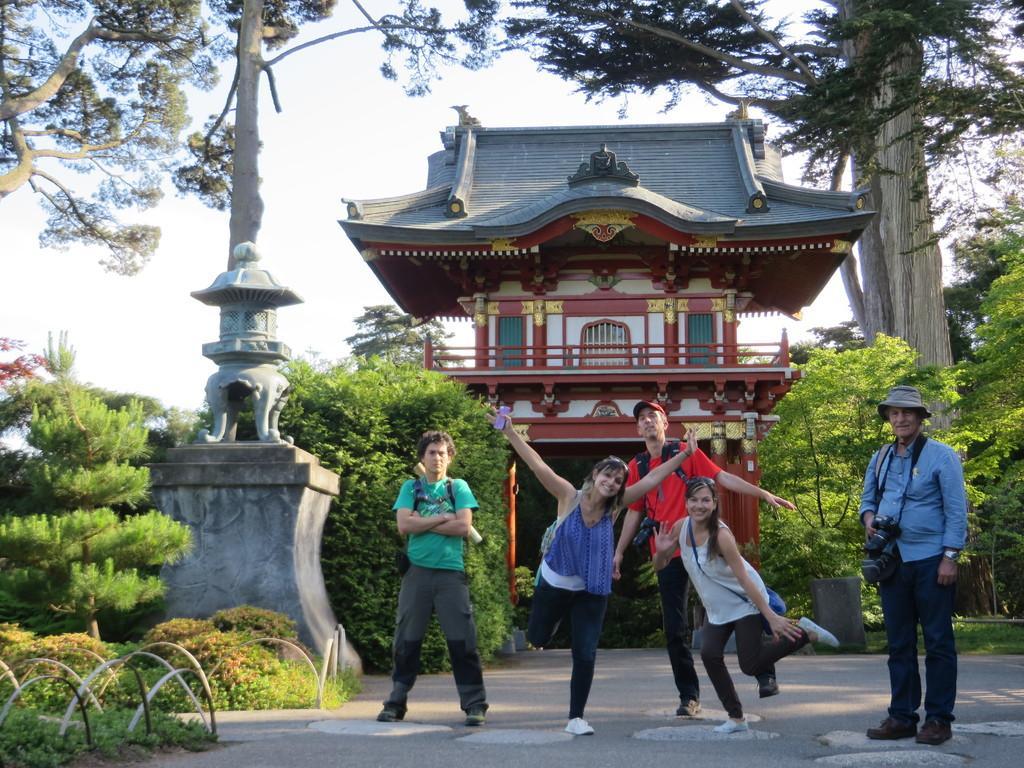Please provide a concise description of this image. In the center of the image we can see persons standing on the road. In the background we can see building, pillar, trees and sky. 